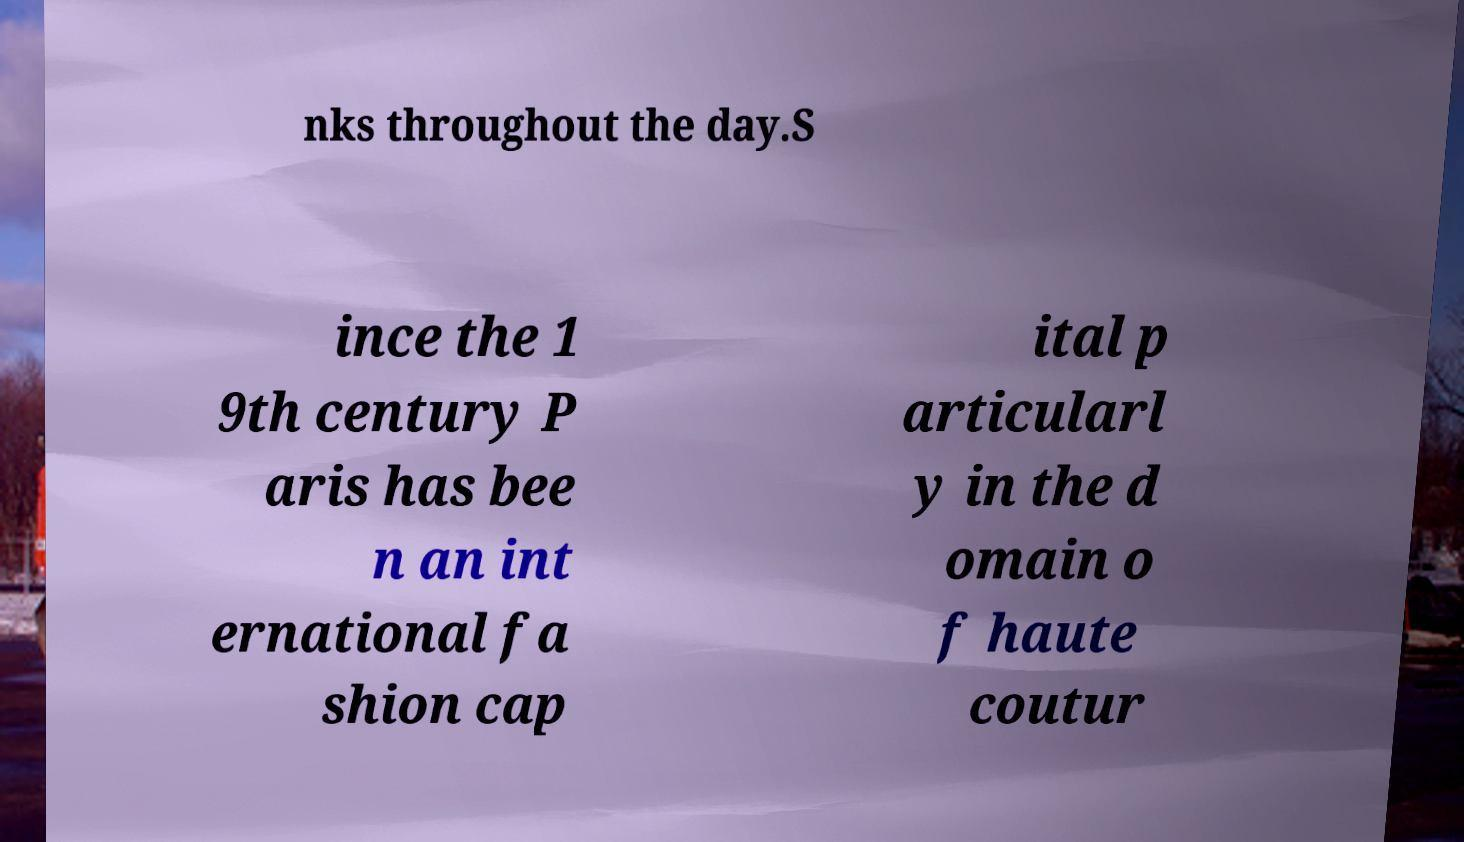Can you read and provide the text displayed in the image?This photo seems to have some interesting text. Can you extract and type it out for me? nks throughout the day.S ince the 1 9th century P aris has bee n an int ernational fa shion cap ital p articularl y in the d omain o f haute coutur 